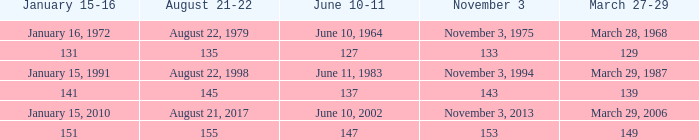What is the number for march 27-29 whern november 3 is 153? 149.0. 